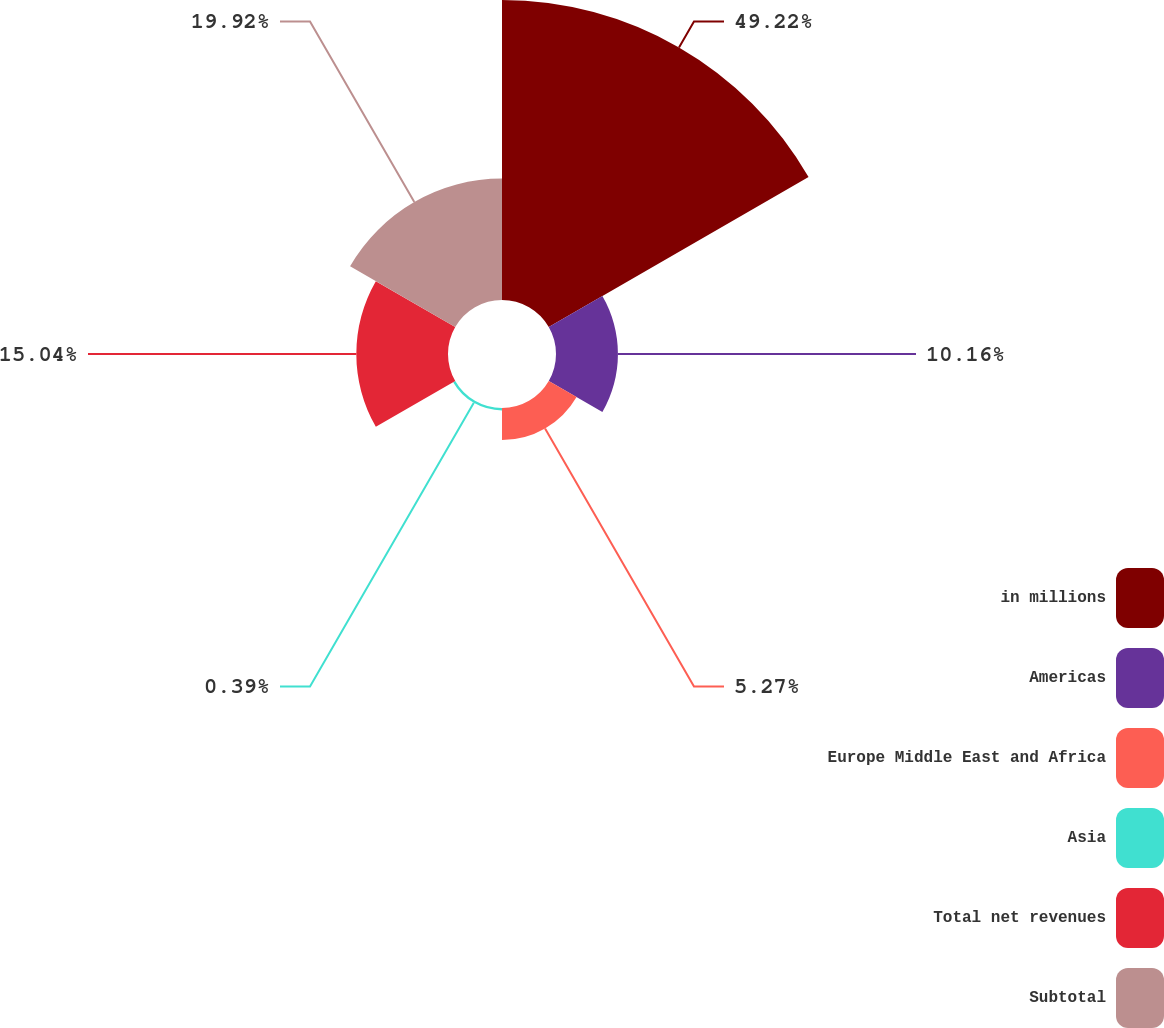<chart> <loc_0><loc_0><loc_500><loc_500><pie_chart><fcel>in millions<fcel>Americas<fcel>Europe Middle East and Africa<fcel>Asia<fcel>Total net revenues<fcel>Subtotal<nl><fcel>49.22%<fcel>10.16%<fcel>5.27%<fcel>0.39%<fcel>15.04%<fcel>19.92%<nl></chart> 